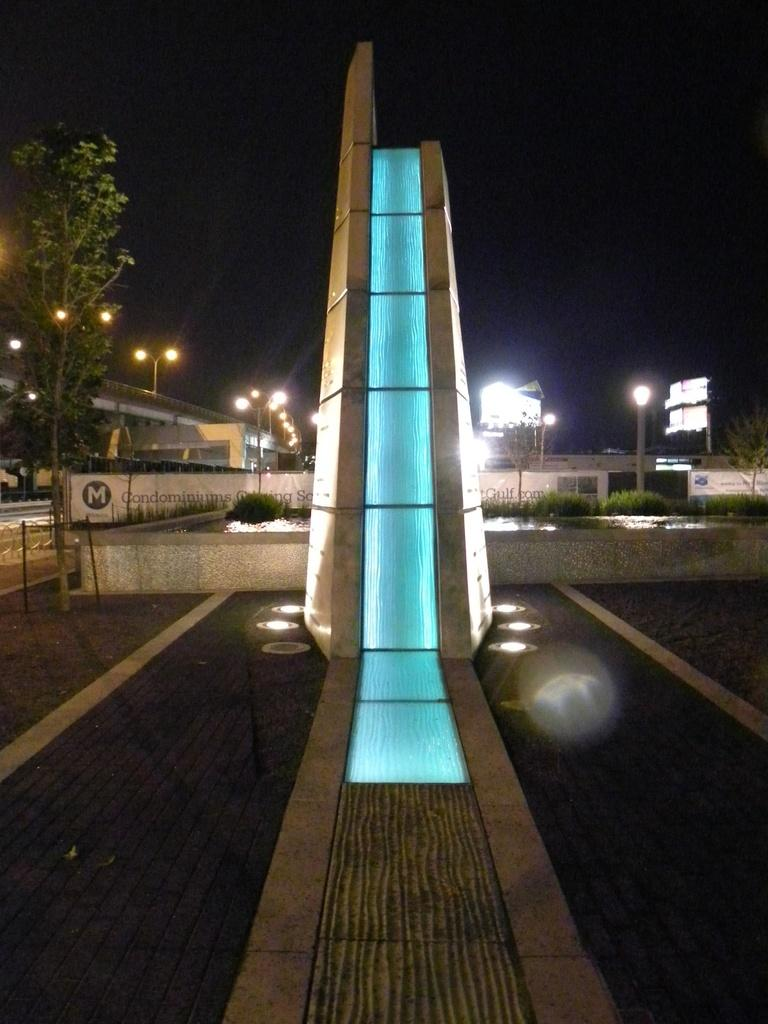What is the main structure in the middle of the image? There is a tower in the middle of the image. What can be seen in the background of the image? There are trees, lights, poles, hoardings, and a bridge in the background of the image. What grade of seed is being used to grow the trees in the image? There is no mention of seeds or tree growth in the image, as it only shows a tower and various background elements. 